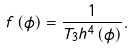<formula> <loc_0><loc_0><loc_500><loc_500>f \left ( \phi \right ) = \frac { 1 } { T _ { 3 } h ^ { 4 } \left ( \phi \right ) } .</formula> 